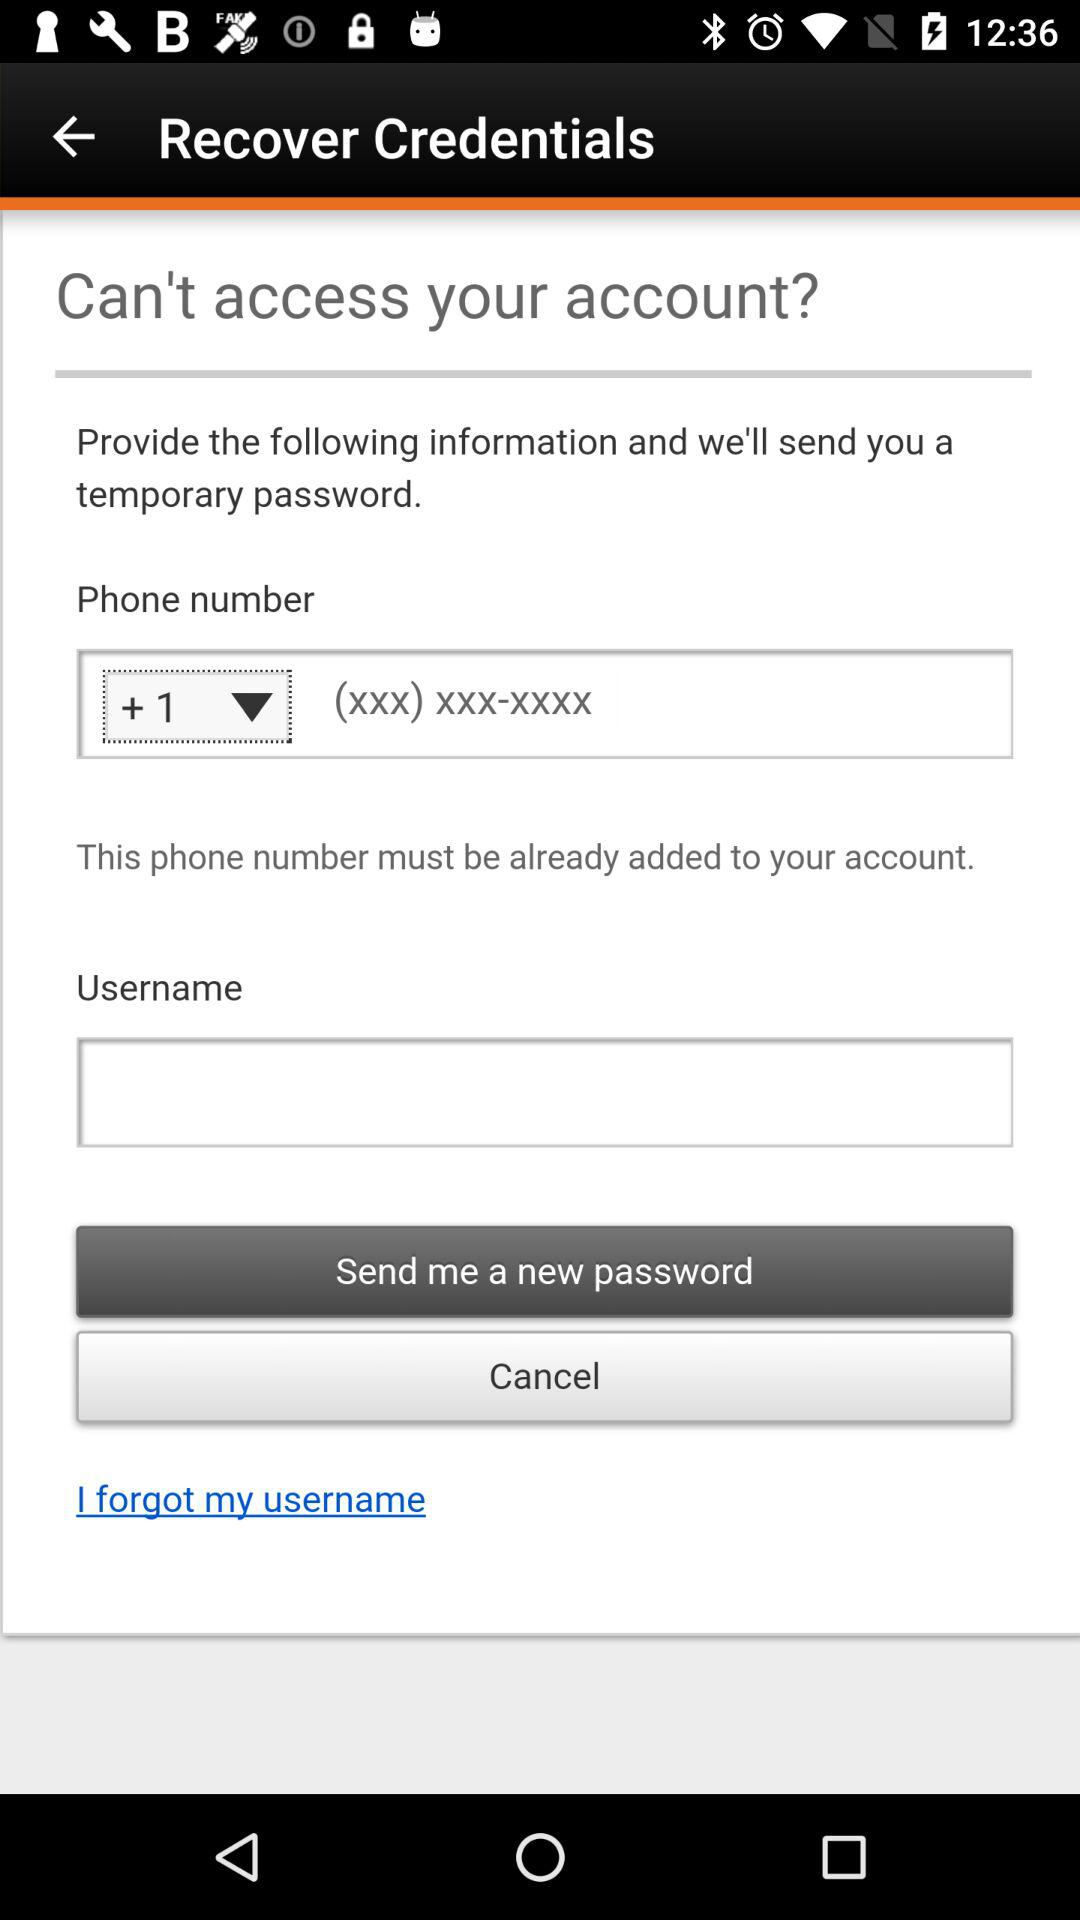How many text inputs are required?
Answer the question using a single word or phrase. 2 